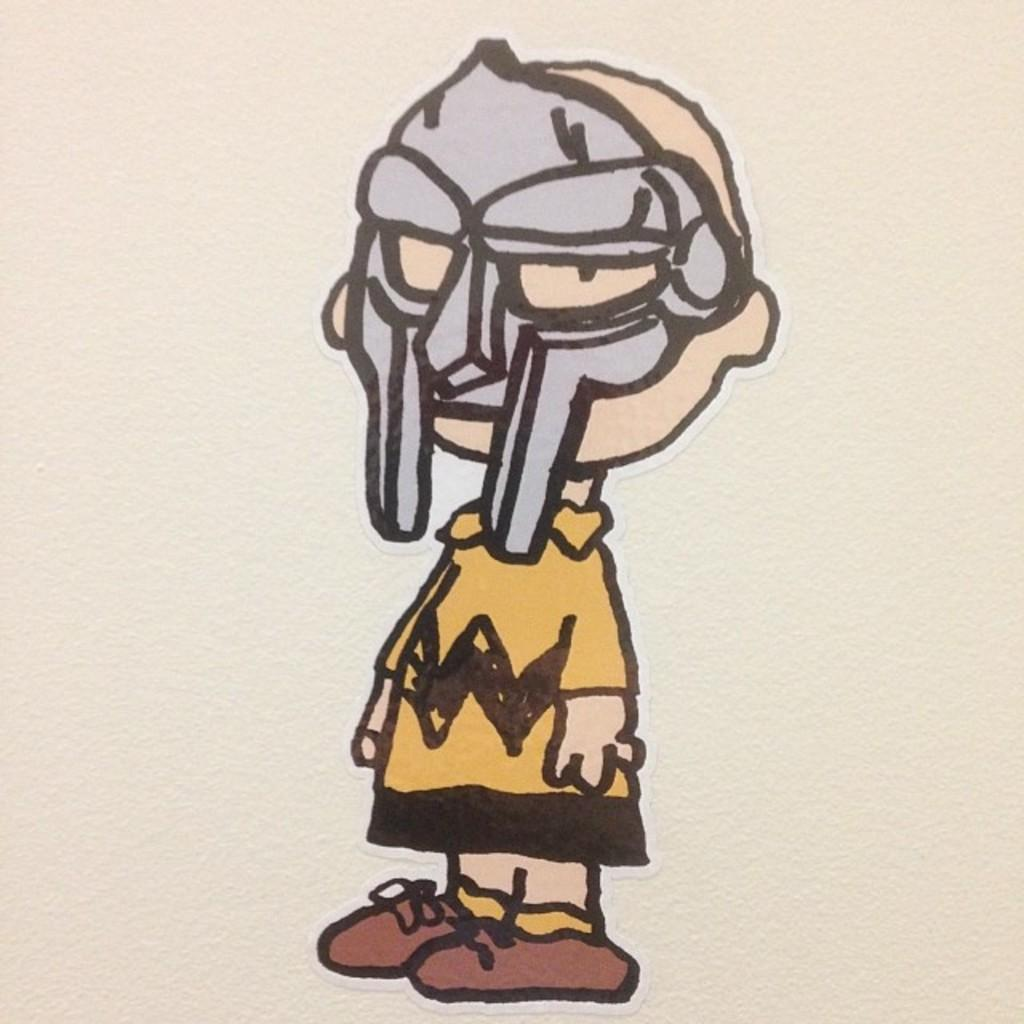What is on the wall in the image? There is a human sticker on the wall. Can you describe the person in the sticker? The person in the sticker is wearing a mask. What type of apparel is the person wearing in the image? The person in the sticker is wearing a mask, but there is no other apparel mentioned in the facts. In which month was the image taken? The facts do not provide any information about the month the image was taken. 